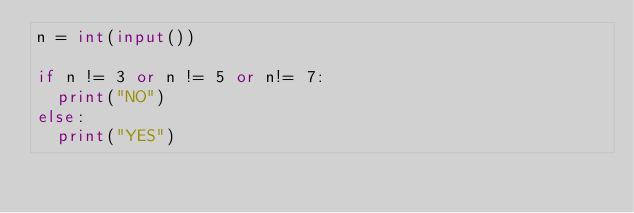Convert code to text. <code><loc_0><loc_0><loc_500><loc_500><_Python_>n = int(input())

if n != 3 or n != 5 or n!= 7:
  print("NO")
else:
  print("YES")</code> 